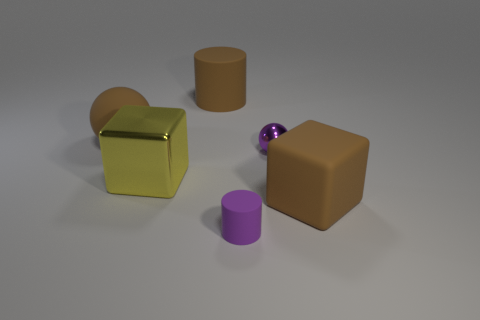Add 2 small yellow balls. How many objects exist? 8 Subtract all cylinders. How many objects are left? 4 Add 3 brown matte spheres. How many brown matte spheres are left? 4 Add 2 brown metal cylinders. How many brown metal cylinders exist? 2 Subtract 0 green spheres. How many objects are left? 6 Subtract all tiny brown cylinders. Subtract all purple matte objects. How many objects are left? 5 